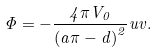<formula> <loc_0><loc_0><loc_500><loc_500>\Phi = - \frac { 4 \pi V _ { 0 } } { \left ( a \pi - d \right ) ^ { 2 } } u v .</formula> 